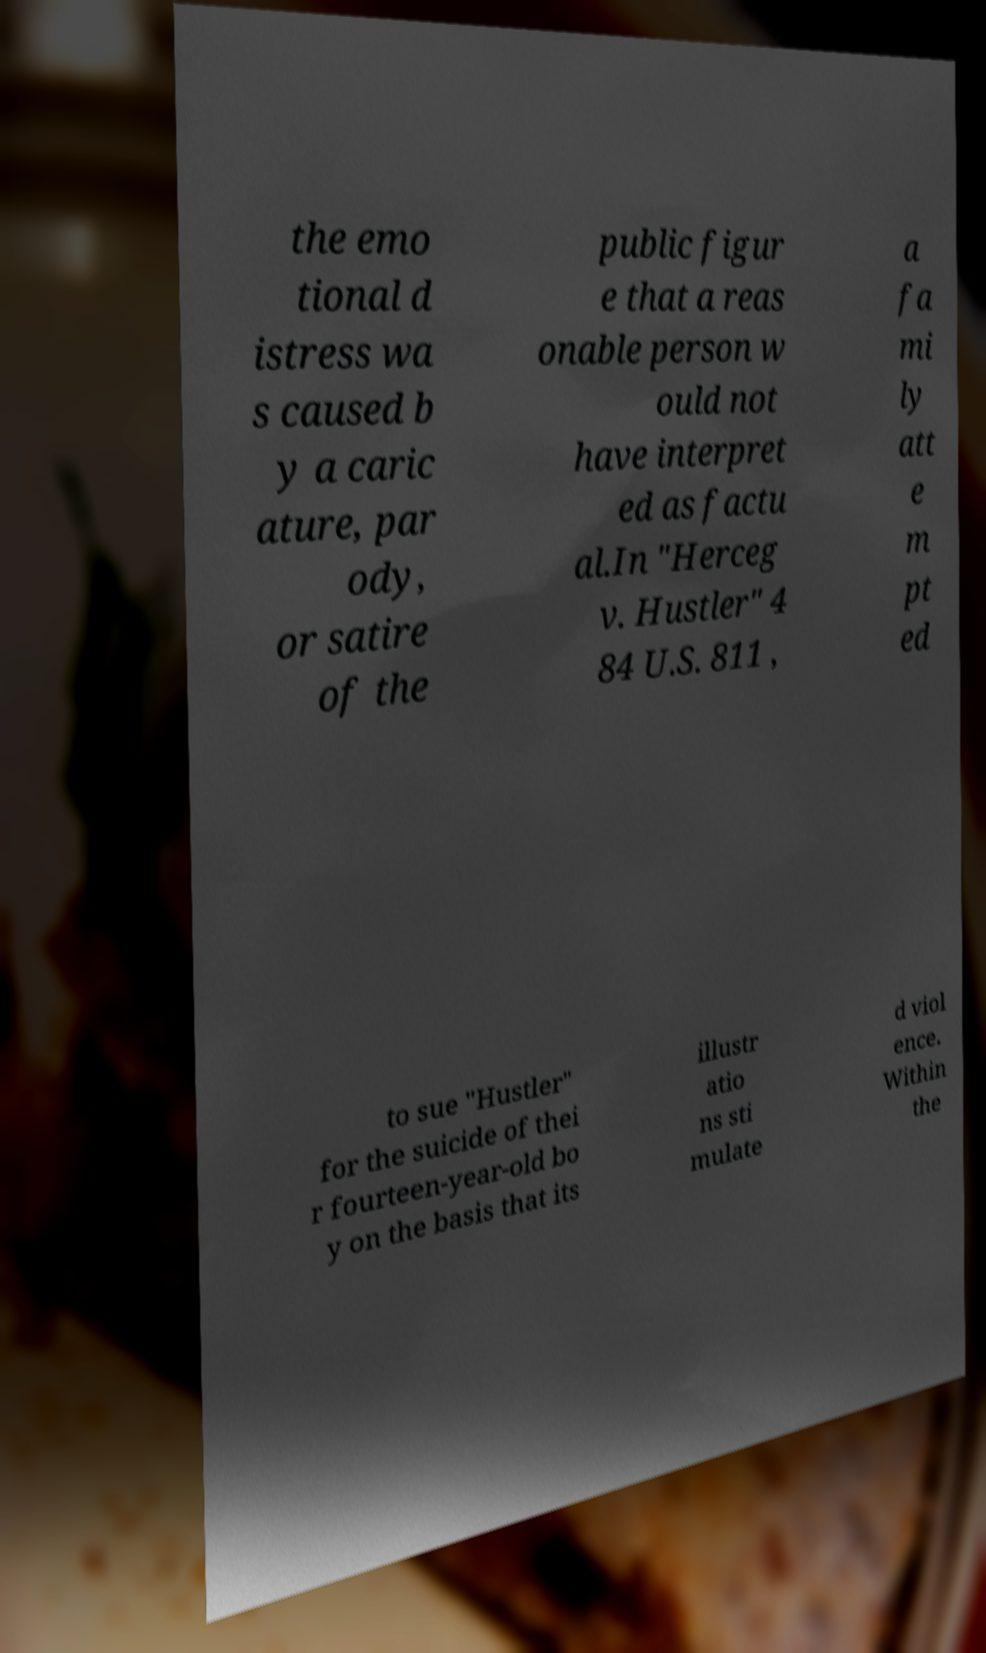Can you read and provide the text displayed in the image?This photo seems to have some interesting text. Can you extract and type it out for me? the emo tional d istress wa s caused b y a caric ature, par ody, or satire of the public figur e that a reas onable person w ould not have interpret ed as factu al.In "Herceg v. Hustler" 4 84 U.S. 811 , a fa mi ly att e m pt ed to sue "Hustler" for the suicide of thei r fourteen-year-old bo y on the basis that its illustr atio ns sti mulate d viol ence. Within the 